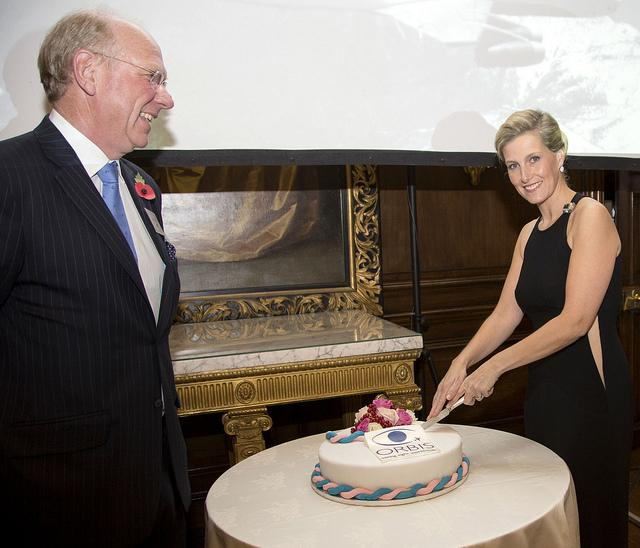What is the name of the red flower on the man's lapel? Please explain your reasoning. poppy. The name is a poppy. 